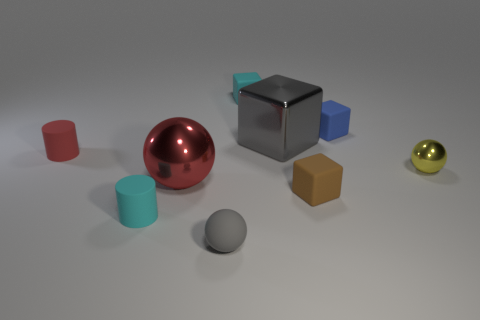The large metal object on the left side of the matte thing in front of the cylinder in front of the small brown rubber block is what shape?
Make the answer very short. Sphere. How many other things are the same shape as the gray matte thing?
Offer a very short reply. 2. There is another ball that is the same size as the yellow shiny ball; what is its color?
Provide a short and direct response. Gray. What number of cylinders are rubber objects or cyan matte objects?
Your answer should be very brief. 2. What number of large gray rubber cylinders are there?
Ensure brevity in your answer.  0. Do the blue matte thing and the big object to the left of the cyan block have the same shape?
Provide a short and direct response. No. There is a ball that is the same color as the big metal block; what is its size?
Keep it short and to the point. Small. How many things are tiny cyan cylinders or yellow spheres?
Make the answer very short. 2. There is a large object that is in front of the small object to the right of the blue object; what shape is it?
Provide a short and direct response. Sphere. There is a cyan thing right of the large metal ball; is it the same shape as the yellow metallic object?
Keep it short and to the point. No. 